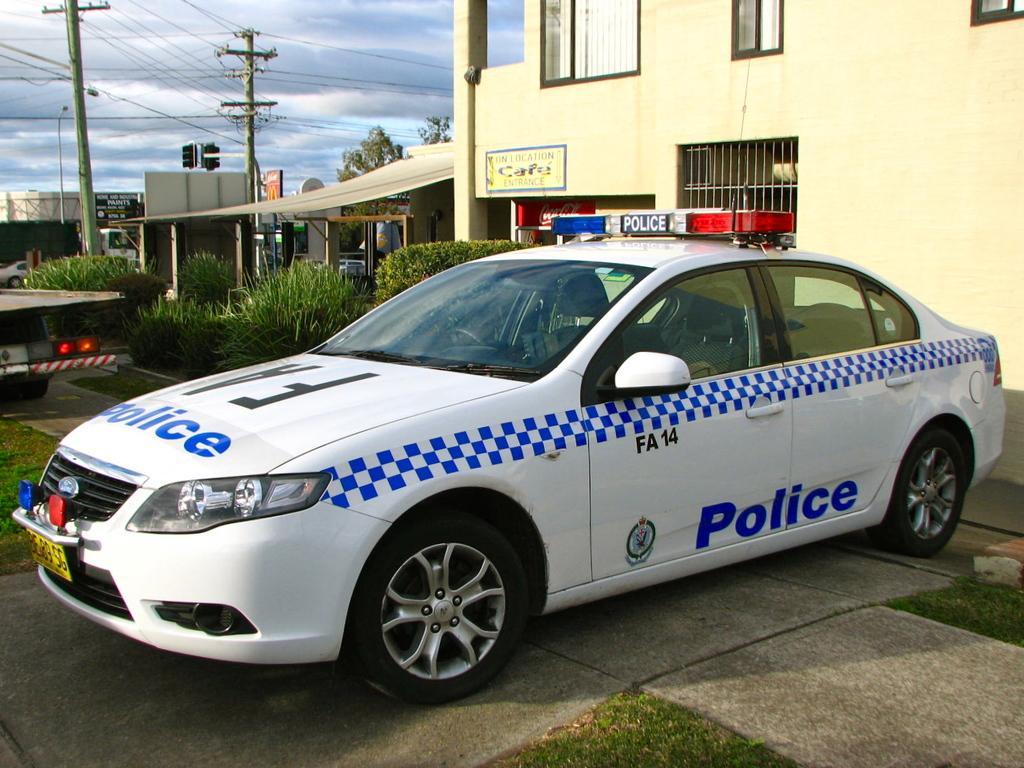How would you summarize this image in a sentence or two? In this image we can see vehicles, grass, plants, boards, poles, trees, and buildings. In the background there is sky with clouds. 